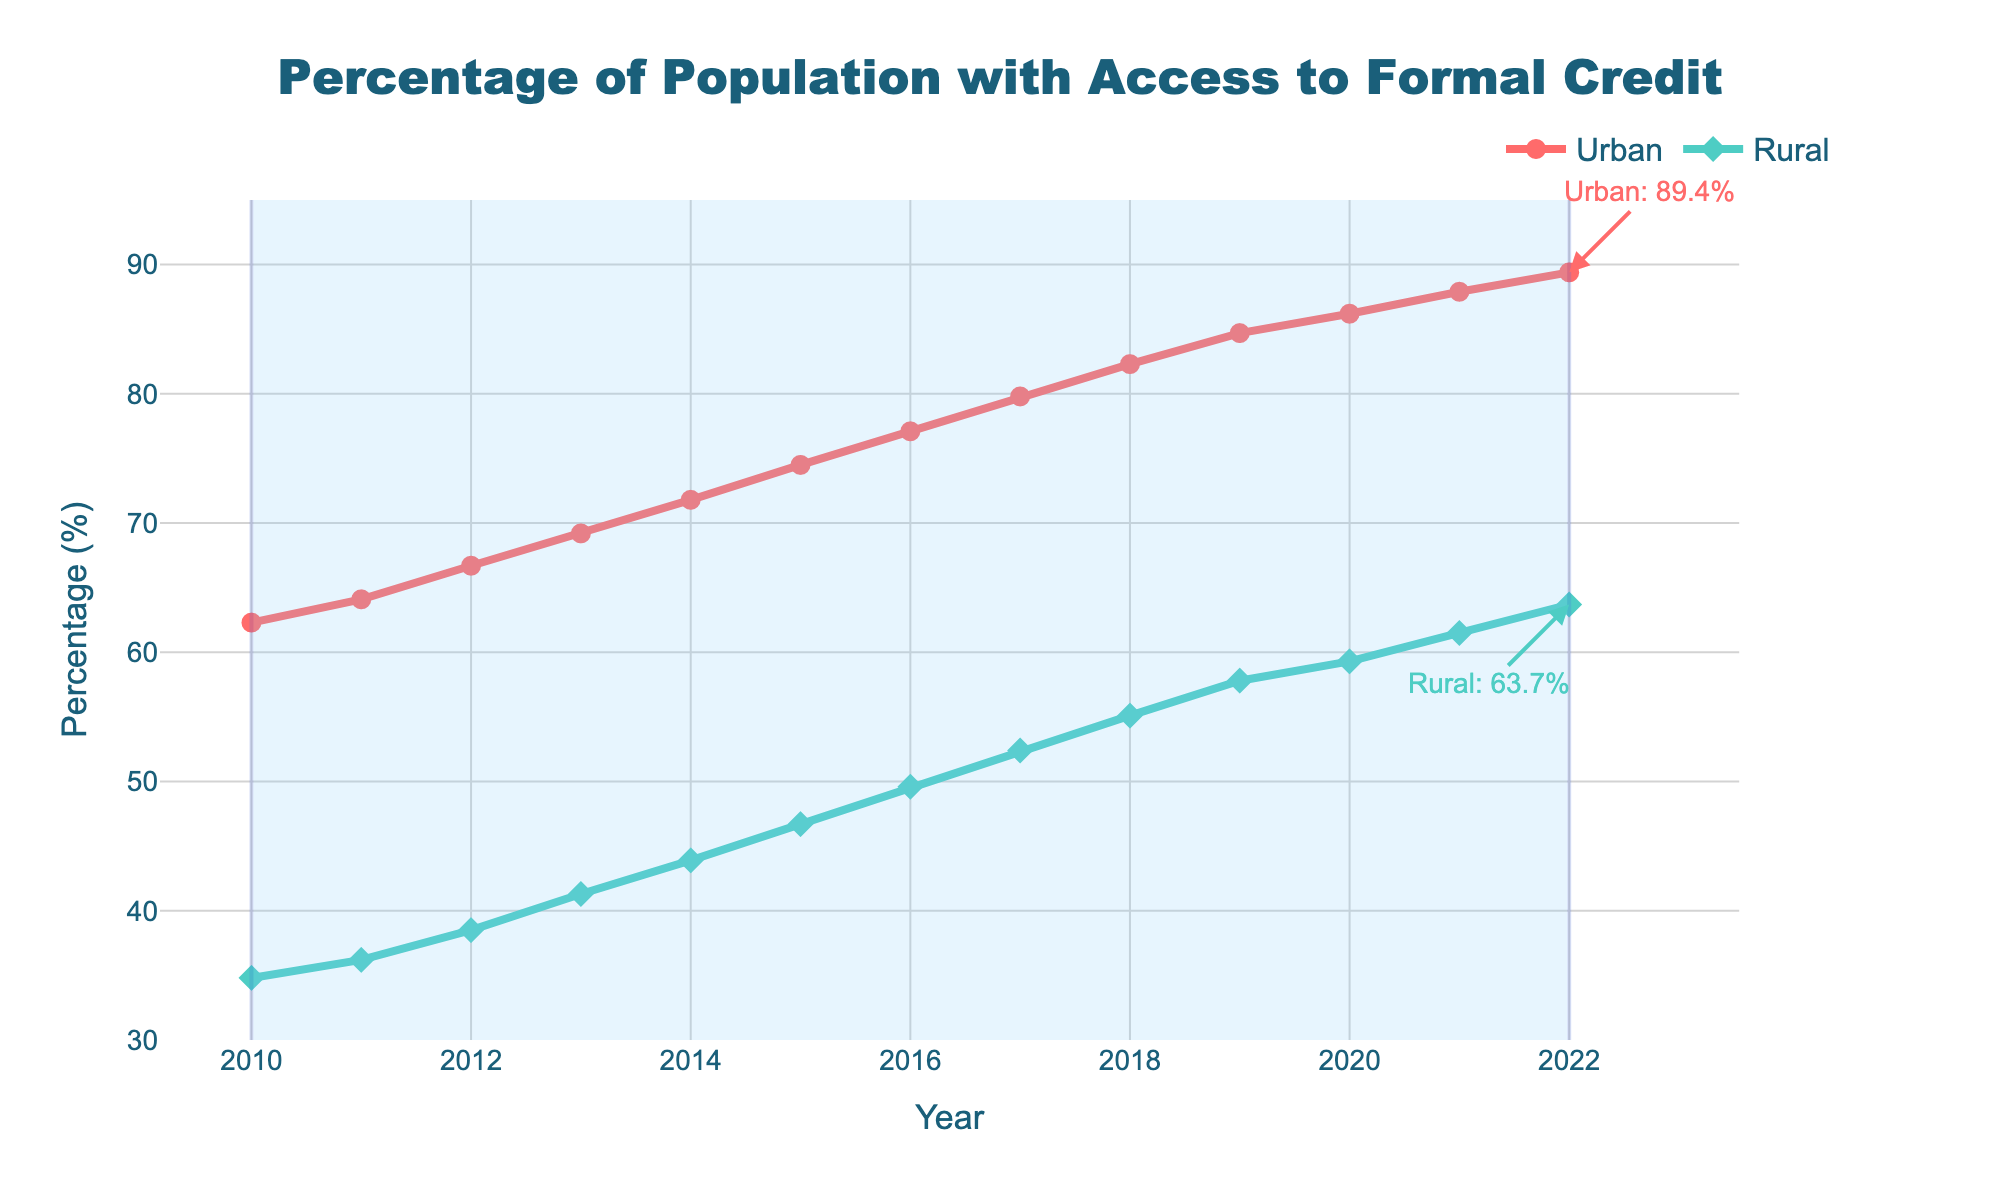What are the percentage increases in access to formal credit in urban areas from 2010 to 2015 and 2015 to 2022? To find the percentage increases, subtract the values for each specified year and then divide by the initial year's value, and multiply by 100. For 2010 to 2015, it's ((74.5 - 62.3) / 62.3) * 100 ≈ 19.5%. For 2015 to 2022, it's ((89.4 - 74.5) / 74.5) * 100 ≈ 20.0%.
Answer: 19.5%, 20.0% Which area, urban or rural, had a higher rate of increase in access to formal credit between 2010 and 2022? First, find the percentage increase for both areas: Urban increased from 62.3% to 89.4% and Rural from 34.8% to 63.7%. For Urban, ((89.4 - 62.3) / 62.3) * 100 ≈ 43.5%. For Rural, ((63.7 - 34.8) / 34.8) * 100 ≈ 83.0%. Compare the two values.
Answer: Rural How does the percentage of the population with access to formal credit in rural areas in 2022 compare to that in urban areas in 2010? The percentage of the population with access to formal credit in rural areas in 2022 is 63.7%, while in urban areas in 2010, it was 62.3%. Compare these values directly.
Answer: Higher By how much did the access to formal credit increase for rural areas from 2010 to 2022? Subtract the percentage in 2010 from the percentage in 2022 for rural areas: 63.7% - 34.8% = 28.9%.
Answer: 28.9% What is the average annual increase in the percentage of urban population with access to formal credit from 2010 to 2022? Calculate the total increase, then divide by the number of years: (89.4 - 62.3) / (2022 - 2010) = 27.1 / 12 ≈ 2.26% per year.
Answer: 2.26% In which year did the urban area surpass 80% in access to formal credit? Identify the year when the percentage for the urban population exceeded 80%. From the data, it is 2018.
Answer: 2018 Observing the trend, what can be said about the gap in access to formal credit between urban and rural areas from 2010 to 2022? Is it widening or narrowing? Calculate the difference for each year and compare over time. The gap in 2010 was 62.3 - 34.8 = 27.5%, and in 2022 it was 89.4 - 63.7 = 25.7%. The gap is narrowing.
Answer: Narrowing 